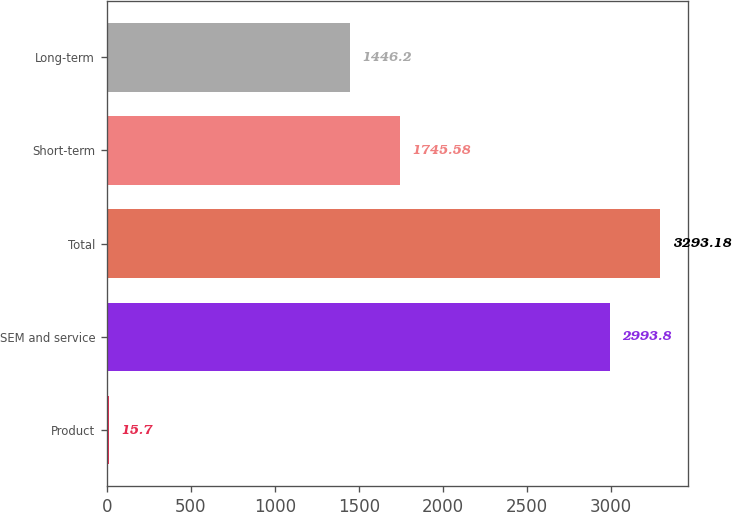Convert chart. <chart><loc_0><loc_0><loc_500><loc_500><bar_chart><fcel>Product<fcel>SEM and service<fcel>Total<fcel>Short-term<fcel>Long-term<nl><fcel>15.7<fcel>2993.8<fcel>3293.18<fcel>1745.58<fcel>1446.2<nl></chart> 